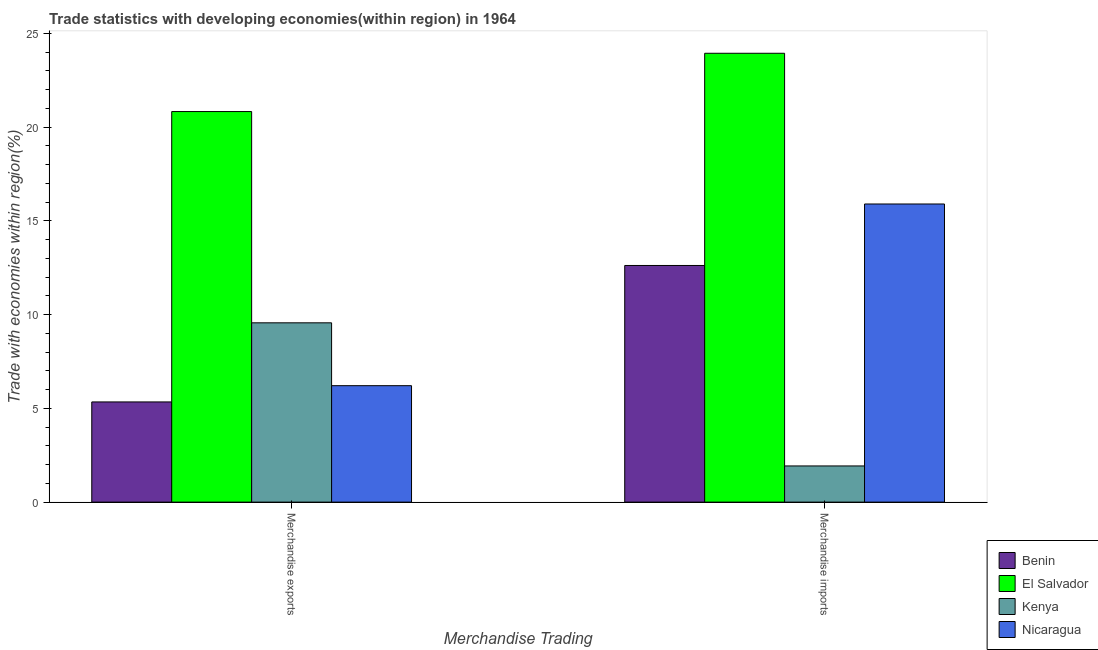Are the number of bars on each tick of the X-axis equal?
Your answer should be compact. Yes. How many bars are there on the 1st tick from the left?
Make the answer very short. 4. How many bars are there on the 1st tick from the right?
Provide a short and direct response. 4. What is the label of the 1st group of bars from the left?
Your answer should be very brief. Merchandise exports. What is the merchandise imports in Benin?
Make the answer very short. 12.62. Across all countries, what is the maximum merchandise imports?
Your answer should be very brief. 23.94. Across all countries, what is the minimum merchandise exports?
Give a very brief answer. 5.34. In which country was the merchandise exports maximum?
Keep it short and to the point. El Salvador. In which country was the merchandise imports minimum?
Your answer should be compact. Kenya. What is the total merchandise imports in the graph?
Offer a very short reply. 54.39. What is the difference between the merchandise imports in Kenya and that in Benin?
Give a very brief answer. -10.69. What is the difference between the merchandise exports in Nicaragua and the merchandise imports in Benin?
Make the answer very short. -6.41. What is the average merchandise exports per country?
Ensure brevity in your answer.  10.49. What is the difference between the merchandise exports and merchandise imports in Kenya?
Your answer should be compact. 7.63. What is the ratio of the merchandise imports in Benin to that in El Salvador?
Give a very brief answer. 0.53. Is the merchandise imports in Benin less than that in El Salvador?
Provide a succinct answer. Yes. What does the 2nd bar from the left in Merchandise exports represents?
Make the answer very short. El Salvador. What does the 1st bar from the right in Merchandise exports represents?
Provide a short and direct response. Nicaragua. Are all the bars in the graph horizontal?
Provide a short and direct response. No. How many legend labels are there?
Offer a very short reply. 4. What is the title of the graph?
Your answer should be very brief. Trade statistics with developing economies(within region) in 1964. Does "Chile" appear as one of the legend labels in the graph?
Provide a succinct answer. No. What is the label or title of the X-axis?
Offer a terse response. Merchandise Trading. What is the label or title of the Y-axis?
Your answer should be very brief. Trade with economies within region(%). What is the Trade with economies within region(%) of Benin in Merchandise exports?
Your answer should be compact. 5.34. What is the Trade with economies within region(%) in El Salvador in Merchandise exports?
Offer a terse response. 20.83. What is the Trade with economies within region(%) in Kenya in Merchandise exports?
Keep it short and to the point. 9.56. What is the Trade with economies within region(%) of Nicaragua in Merchandise exports?
Provide a short and direct response. 6.21. What is the Trade with economies within region(%) in Benin in Merchandise imports?
Keep it short and to the point. 12.62. What is the Trade with economies within region(%) of El Salvador in Merchandise imports?
Provide a short and direct response. 23.94. What is the Trade with economies within region(%) of Kenya in Merchandise imports?
Give a very brief answer. 1.93. What is the Trade with economies within region(%) in Nicaragua in Merchandise imports?
Your response must be concise. 15.9. Across all Merchandise Trading, what is the maximum Trade with economies within region(%) in Benin?
Ensure brevity in your answer.  12.62. Across all Merchandise Trading, what is the maximum Trade with economies within region(%) of El Salvador?
Your answer should be compact. 23.94. Across all Merchandise Trading, what is the maximum Trade with economies within region(%) of Kenya?
Offer a very short reply. 9.56. Across all Merchandise Trading, what is the maximum Trade with economies within region(%) of Nicaragua?
Offer a terse response. 15.9. Across all Merchandise Trading, what is the minimum Trade with economies within region(%) in Benin?
Give a very brief answer. 5.34. Across all Merchandise Trading, what is the minimum Trade with economies within region(%) in El Salvador?
Offer a very short reply. 20.83. Across all Merchandise Trading, what is the minimum Trade with economies within region(%) in Kenya?
Make the answer very short. 1.93. Across all Merchandise Trading, what is the minimum Trade with economies within region(%) of Nicaragua?
Your response must be concise. 6.21. What is the total Trade with economies within region(%) in Benin in the graph?
Provide a short and direct response. 17.96. What is the total Trade with economies within region(%) in El Salvador in the graph?
Your answer should be very brief. 44.77. What is the total Trade with economies within region(%) of Kenya in the graph?
Provide a succinct answer. 11.49. What is the total Trade with economies within region(%) of Nicaragua in the graph?
Provide a succinct answer. 22.11. What is the difference between the Trade with economies within region(%) in Benin in Merchandise exports and that in Merchandise imports?
Offer a terse response. -7.28. What is the difference between the Trade with economies within region(%) in El Salvador in Merchandise exports and that in Merchandise imports?
Provide a short and direct response. -3.11. What is the difference between the Trade with economies within region(%) of Kenya in Merchandise exports and that in Merchandise imports?
Offer a very short reply. 7.63. What is the difference between the Trade with economies within region(%) in Nicaragua in Merchandise exports and that in Merchandise imports?
Your response must be concise. -9.69. What is the difference between the Trade with economies within region(%) in Benin in Merchandise exports and the Trade with economies within region(%) in El Salvador in Merchandise imports?
Your response must be concise. -18.6. What is the difference between the Trade with economies within region(%) in Benin in Merchandise exports and the Trade with economies within region(%) in Kenya in Merchandise imports?
Offer a terse response. 3.41. What is the difference between the Trade with economies within region(%) of Benin in Merchandise exports and the Trade with economies within region(%) of Nicaragua in Merchandise imports?
Provide a short and direct response. -10.56. What is the difference between the Trade with economies within region(%) of El Salvador in Merchandise exports and the Trade with economies within region(%) of Kenya in Merchandise imports?
Offer a very short reply. 18.9. What is the difference between the Trade with economies within region(%) of El Salvador in Merchandise exports and the Trade with economies within region(%) of Nicaragua in Merchandise imports?
Offer a terse response. 4.93. What is the difference between the Trade with economies within region(%) in Kenya in Merchandise exports and the Trade with economies within region(%) in Nicaragua in Merchandise imports?
Your answer should be very brief. -6.34. What is the average Trade with economies within region(%) of Benin per Merchandise Trading?
Your response must be concise. 8.98. What is the average Trade with economies within region(%) in El Salvador per Merchandise Trading?
Your answer should be very brief. 22.39. What is the average Trade with economies within region(%) of Kenya per Merchandise Trading?
Your answer should be very brief. 5.75. What is the average Trade with economies within region(%) in Nicaragua per Merchandise Trading?
Ensure brevity in your answer.  11.06. What is the difference between the Trade with economies within region(%) of Benin and Trade with economies within region(%) of El Salvador in Merchandise exports?
Provide a short and direct response. -15.49. What is the difference between the Trade with economies within region(%) in Benin and Trade with economies within region(%) in Kenya in Merchandise exports?
Offer a very short reply. -4.22. What is the difference between the Trade with economies within region(%) of Benin and Trade with economies within region(%) of Nicaragua in Merchandise exports?
Provide a succinct answer. -0.87. What is the difference between the Trade with economies within region(%) in El Salvador and Trade with economies within region(%) in Kenya in Merchandise exports?
Give a very brief answer. 11.27. What is the difference between the Trade with economies within region(%) in El Salvador and Trade with economies within region(%) in Nicaragua in Merchandise exports?
Provide a short and direct response. 14.62. What is the difference between the Trade with economies within region(%) in Kenya and Trade with economies within region(%) in Nicaragua in Merchandise exports?
Your answer should be very brief. 3.35. What is the difference between the Trade with economies within region(%) in Benin and Trade with economies within region(%) in El Salvador in Merchandise imports?
Give a very brief answer. -11.32. What is the difference between the Trade with economies within region(%) of Benin and Trade with economies within region(%) of Kenya in Merchandise imports?
Offer a terse response. 10.69. What is the difference between the Trade with economies within region(%) of Benin and Trade with economies within region(%) of Nicaragua in Merchandise imports?
Give a very brief answer. -3.28. What is the difference between the Trade with economies within region(%) of El Salvador and Trade with economies within region(%) of Kenya in Merchandise imports?
Provide a short and direct response. 22.01. What is the difference between the Trade with economies within region(%) of El Salvador and Trade with economies within region(%) of Nicaragua in Merchandise imports?
Provide a short and direct response. 8.04. What is the difference between the Trade with economies within region(%) in Kenya and Trade with economies within region(%) in Nicaragua in Merchandise imports?
Provide a short and direct response. -13.97. What is the ratio of the Trade with economies within region(%) of Benin in Merchandise exports to that in Merchandise imports?
Ensure brevity in your answer.  0.42. What is the ratio of the Trade with economies within region(%) of El Salvador in Merchandise exports to that in Merchandise imports?
Your answer should be very brief. 0.87. What is the ratio of the Trade with economies within region(%) of Kenya in Merchandise exports to that in Merchandise imports?
Keep it short and to the point. 4.96. What is the ratio of the Trade with economies within region(%) of Nicaragua in Merchandise exports to that in Merchandise imports?
Provide a succinct answer. 0.39. What is the difference between the highest and the second highest Trade with economies within region(%) of Benin?
Give a very brief answer. 7.28. What is the difference between the highest and the second highest Trade with economies within region(%) in El Salvador?
Your response must be concise. 3.11. What is the difference between the highest and the second highest Trade with economies within region(%) of Kenya?
Your response must be concise. 7.63. What is the difference between the highest and the second highest Trade with economies within region(%) of Nicaragua?
Offer a terse response. 9.69. What is the difference between the highest and the lowest Trade with economies within region(%) in Benin?
Provide a short and direct response. 7.28. What is the difference between the highest and the lowest Trade with economies within region(%) of El Salvador?
Your response must be concise. 3.11. What is the difference between the highest and the lowest Trade with economies within region(%) of Kenya?
Provide a succinct answer. 7.63. What is the difference between the highest and the lowest Trade with economies within region(%) in Nicaragua?
Make the answer very short. 9.69. 